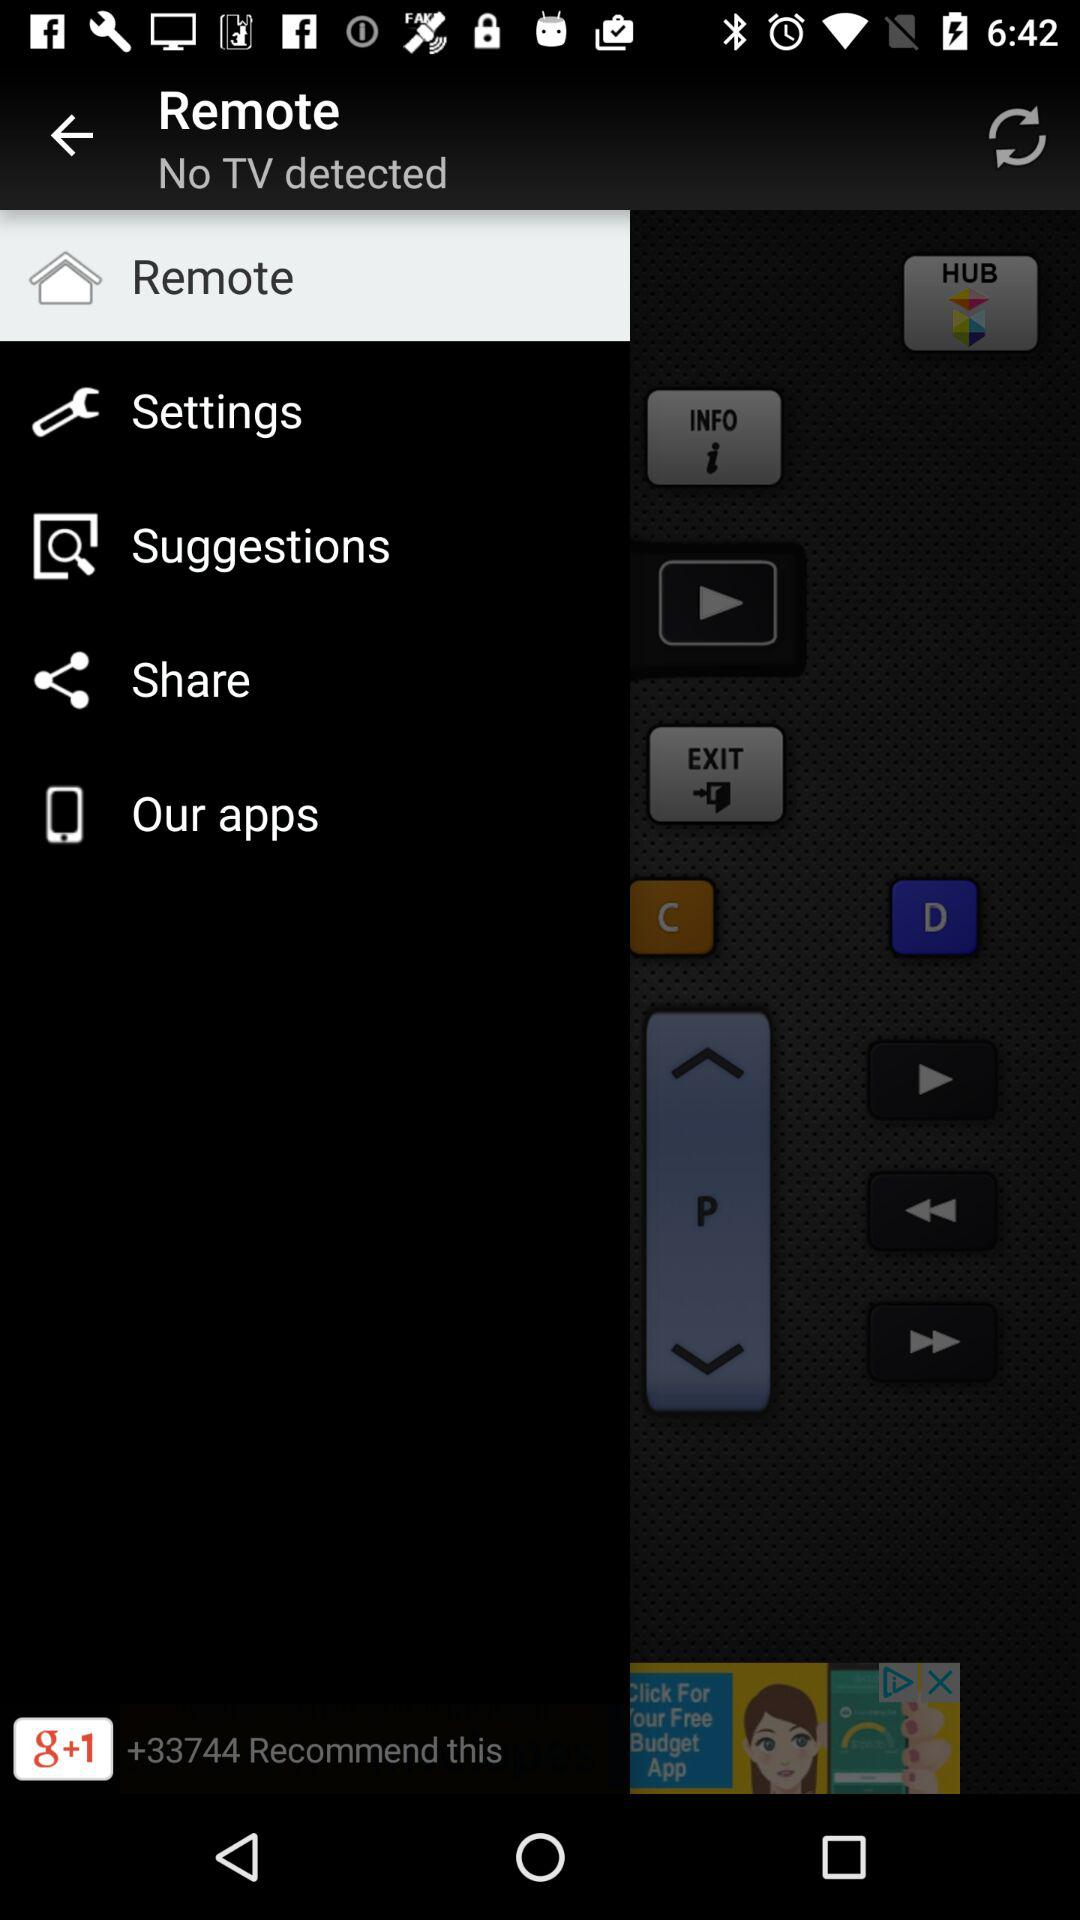Which option is selected? The selected option is "Remote". 